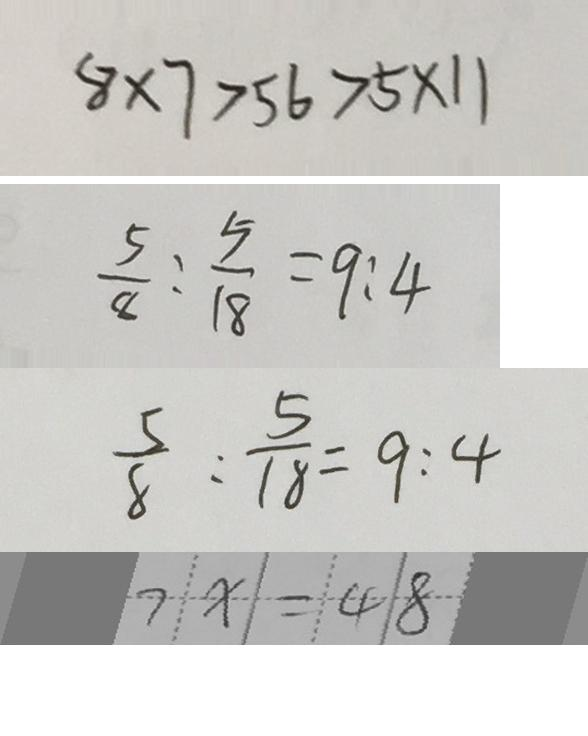Convert formula to latex. <formula><loc_0><loc_0><loc_500><loc_500>8 \times 7 > 5 6 > 5 \times 1 1 
 \frac { 5 } { 8 } : \frac { 5 } { 1 8 } = 9 : 4 
 \frac { 5 } { 8 } : \frac { 5 } { 1 8 } = 9 : 4 
 7 x = 4 8</formula> 